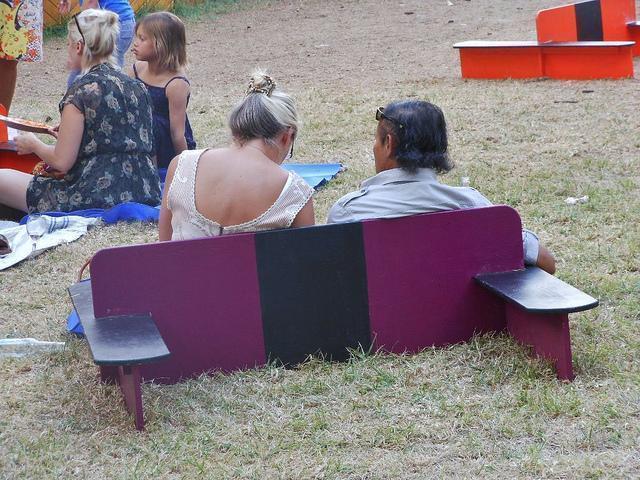Why are they so close together?
Choose the right answer from the provided options to respond to the question.
Options: Save money, little space, protection, friends. Friends. 